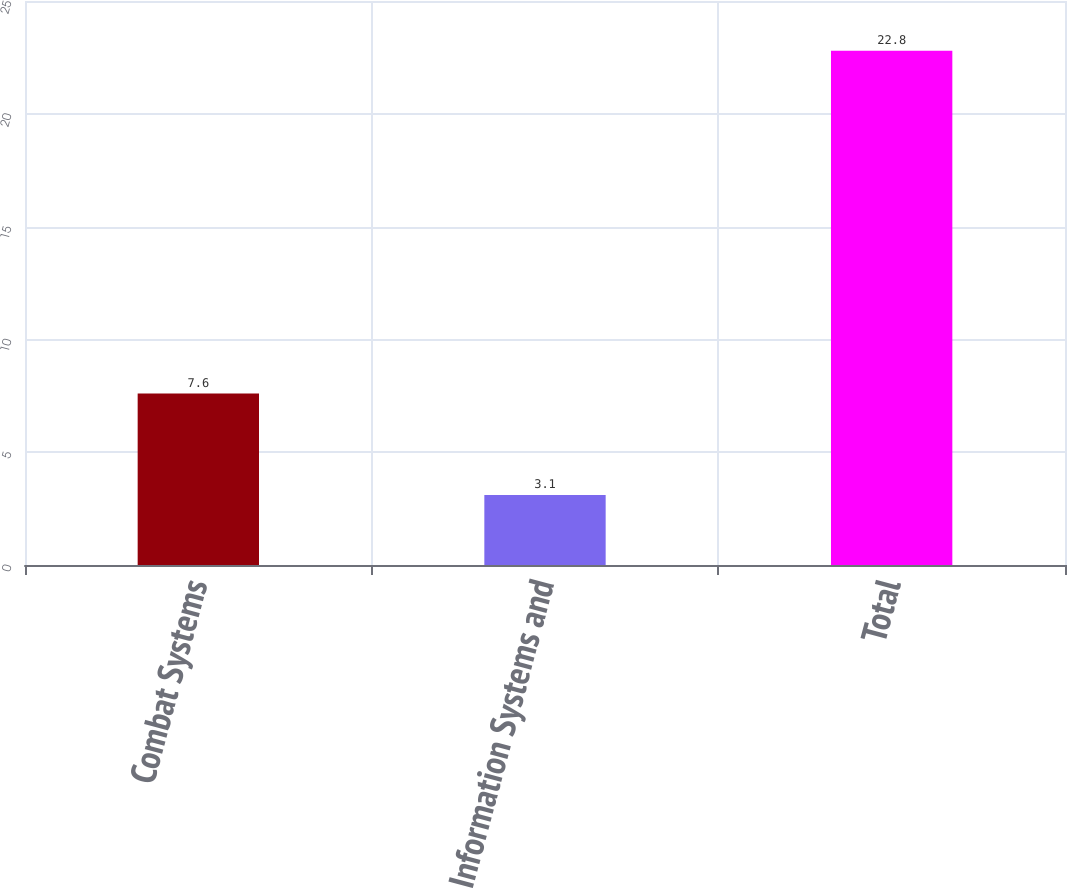Convert chart. <chart><loc_0><loc_0><loc_500><loc_500><bar_chart><fcel>Combat Systems<fcel>Information Systems and<fcel>Total<nl><fcel>7.6<fcel>3.1<fcel>22.8<nl></chart> 